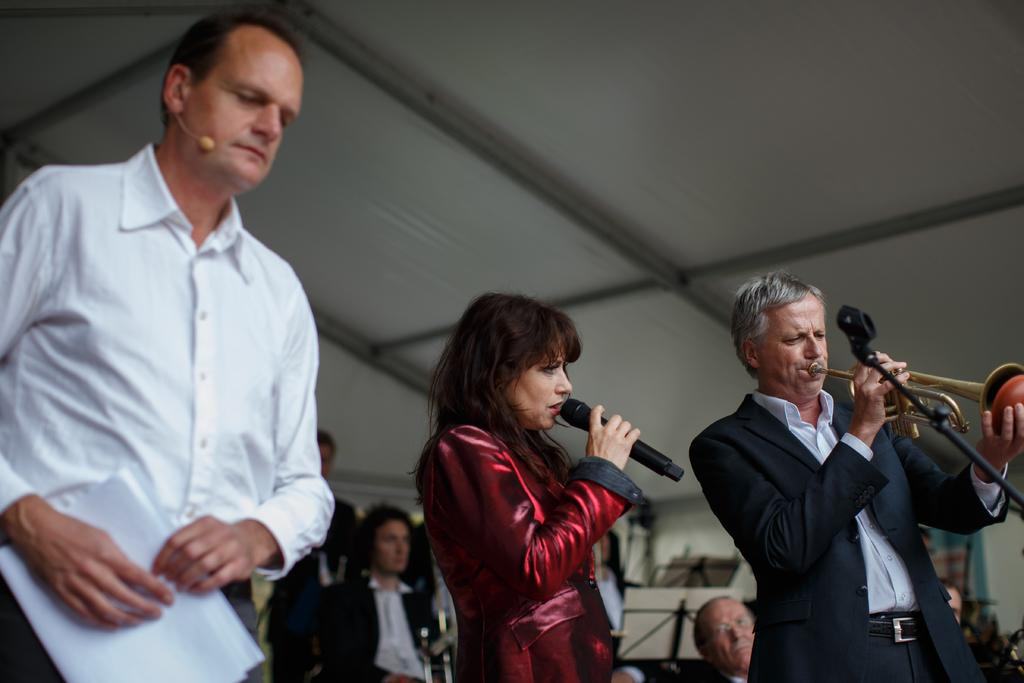What are the people in the image doing? The group of people in the image are playing musical instruments. Can you describe the person on the left side of the image? The person on the left side of the image is wearing a white shirt. What is the person with the white shirt holding? The person with the white shirt is holding a paper. What type of can is visible in the image? There is no can present in the image. Can you describe the circle that is part of the musical instruments being played? The provided facts do not mention any specific musical instruments or their components, so it is not possible to describe a circle as part of the instruments being played. 